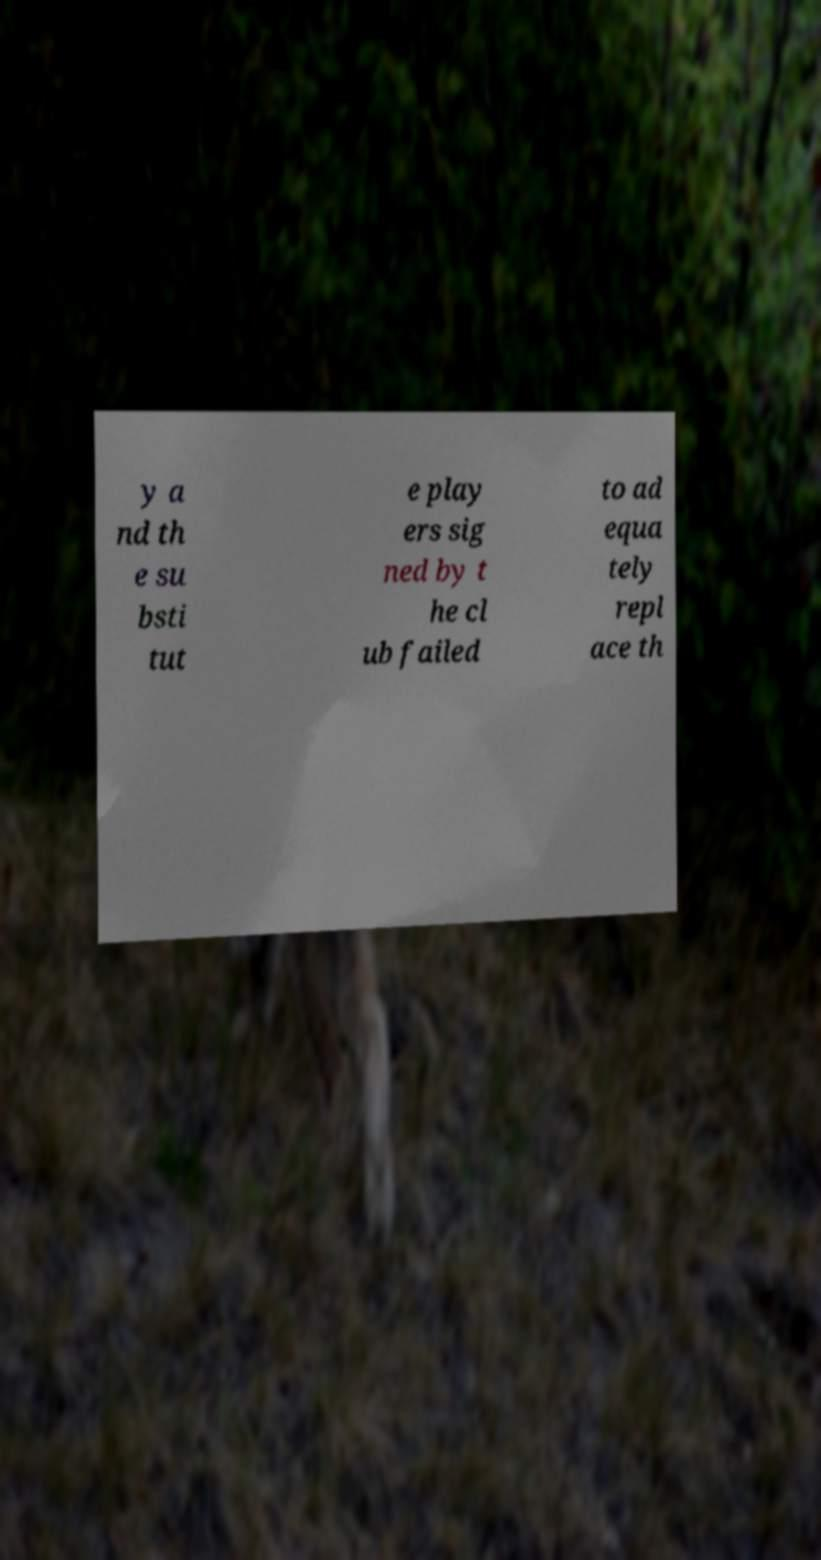I need the written content from this picture converted into text. Can you do that? y a nd th e su bsti tut e play ers sig ned by t he cl ub failed to ad equa tely repl ace th 